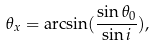<formula> <loc_0><loc_0><loc_500><loc_500>\theta _ { x } = \arcsin ( \frac { \sin \theta _ { 0 } } { \sin i } ) ,</formula> 